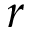Convert formula to latex. <formula><loc_0><loc_0><loc_500><loc_500>r</formula> 